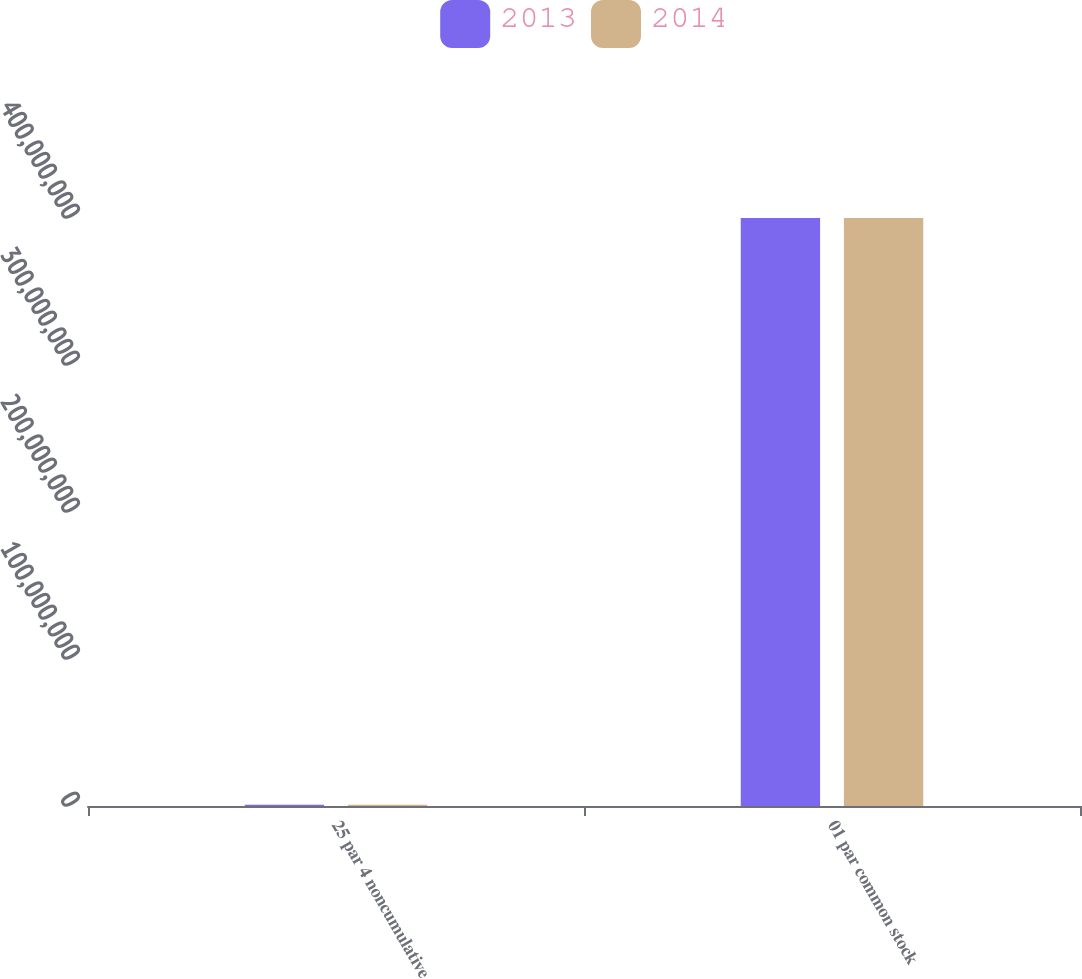Convert chart to OTSL. <chart><loc_0><loc_0><loc_500><loc_500><stacked_bar_chart><ecel><fcel>25 par 4 noncumulative<fcel>01 par common stock<nl><fcel>2013<fcel>840000<fcel>4e+08<nl><fcel>2014<fcel>840000<fcel>4e+08<nl></chart> 